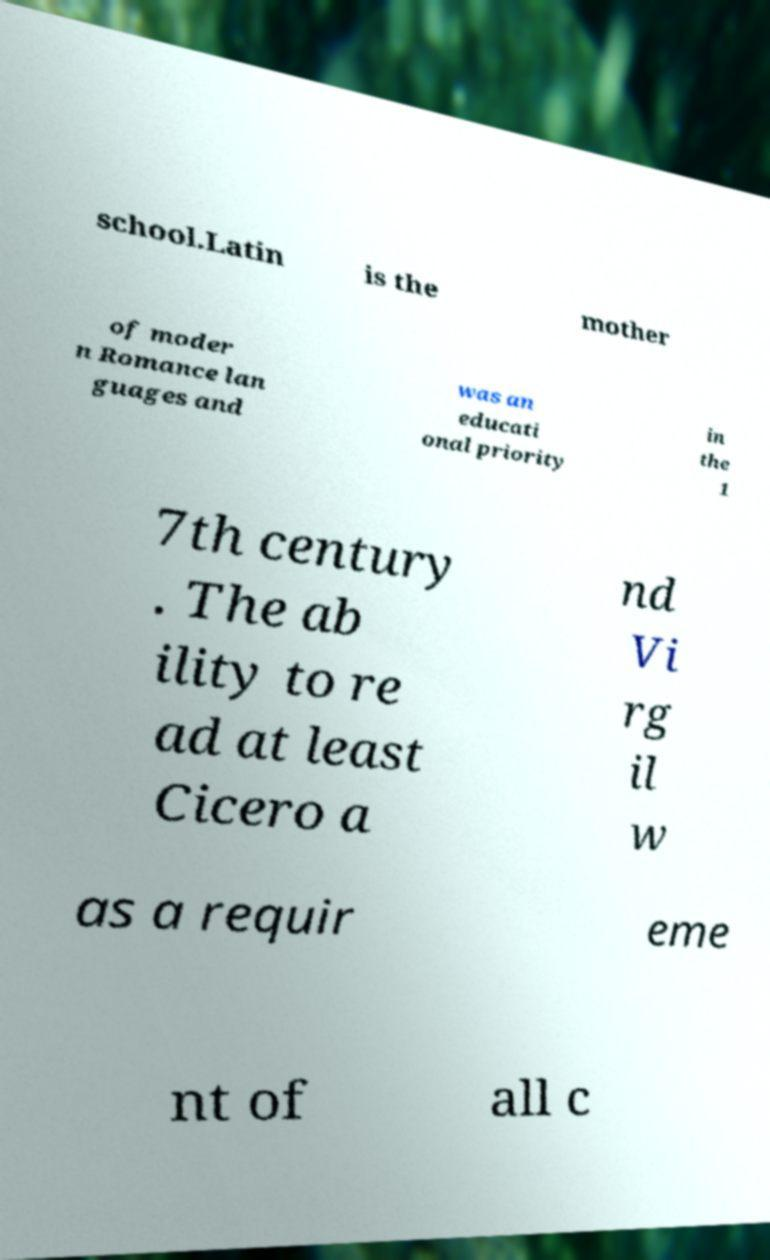For documentation purposes, I need the text within this image transcribed. Could you provide that? school.Latin is the mother of moder n Romance lan guages and was an educati onal priority in the 1 7th century . The ab ility to re ad at least Cicero a nd Vi rg il w as a requir eme nt of all c 